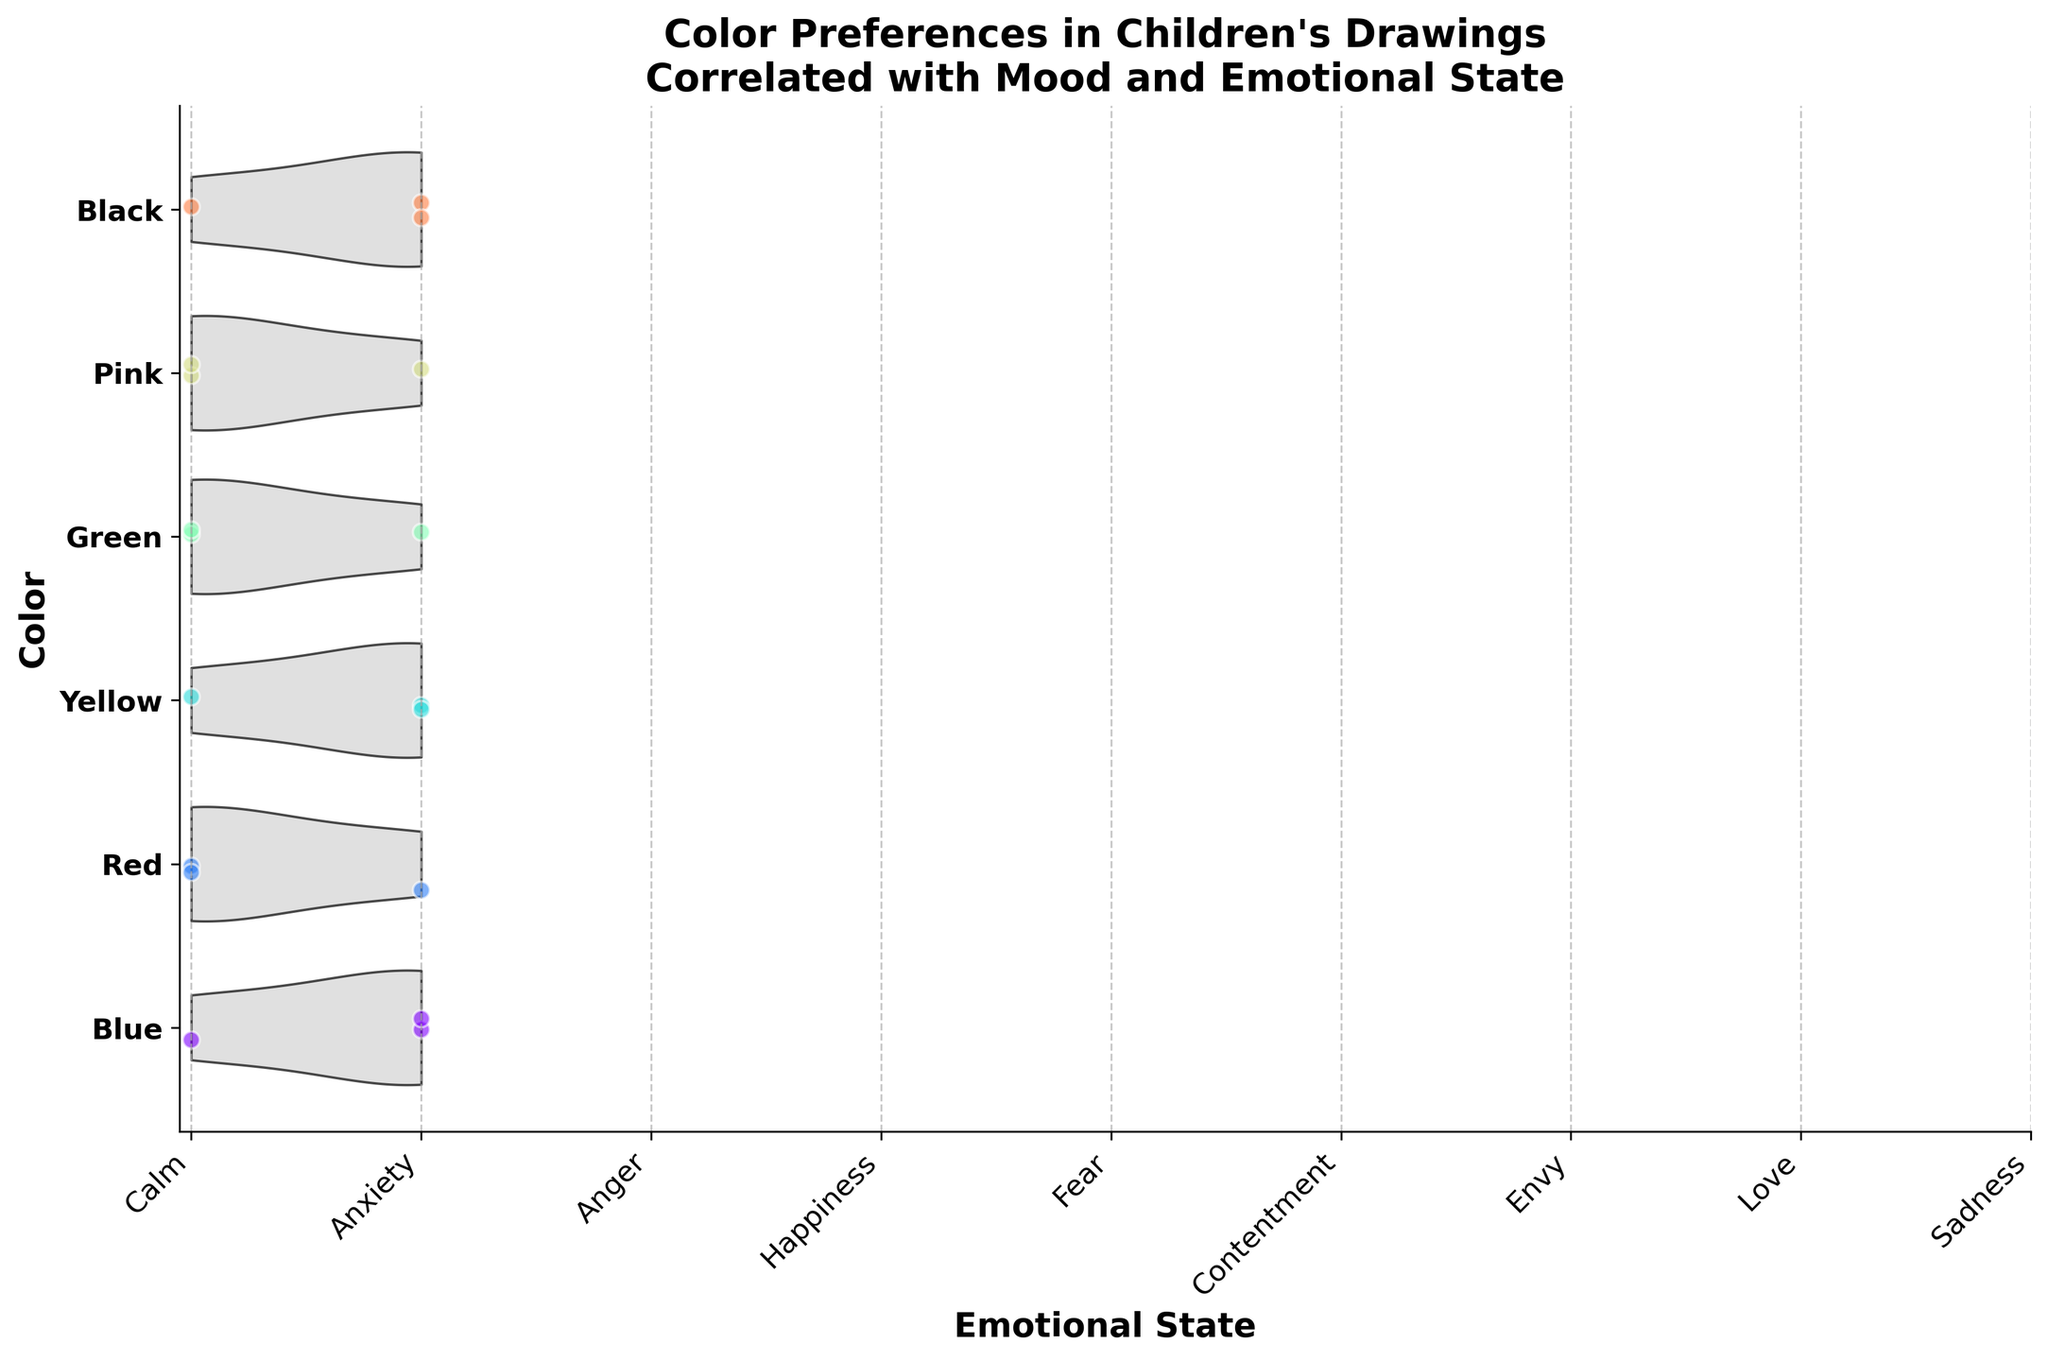What is the title of the figure? The title is located at the top of the figure and should be easily visible as it is in bold.
Answer: "Color Preferences in Children's Drawings\nCorrelated with Mood and Emotional State" Which color has the highest variety of emotional states? Count the different emotional states associated with each color by observing the spread of data points for each color along the x-axis.
Answer: Blue How many emotional states are associated with Red? Identify the unique emotional states along the x-axis for the Red color by looking at the scatter points.
Answer: 3 What emotional state is most frequently associated with Black? Look for the densest area on the x-axis for the Black color to determine the most common emotional state.
Answer: Sadness Are there more emotional states associated with Green or Yellow? Compare the number of unique emotional states on the x-axis for both Green and Yellow colors.
Answer: Green What is the emotional state with the least representation across all colors? Count the number of times each emotional state appears across all colors and identify the lowest frequency.
Answer: Envy Which color is associated with both positive (e.g., Happiness) and negative (e.g., Anger) emotions? Check for any colors that show scatter points in both positive and negative emotional states on the x-axis.
Answer: Red Which emotional state has the widest distribution across multiple colors? Identify the emotional state that appears across the most different colors by checking the x-axis for scatter points.
Answer: Sadness Between the emotions of Fear and Contentment, which one has a representation in a warmer color? Look for scatter points of Fear and Contentment among the colors and identify if they are in warm colors (e.g., Red, Yellow, Pink).
Answer: Fear What might be inferred about children's mood when they choose Yellow color? Look at the emotions and moods associated with Yellow and interpret the emotional states.
Answer: Happy and Energetic 